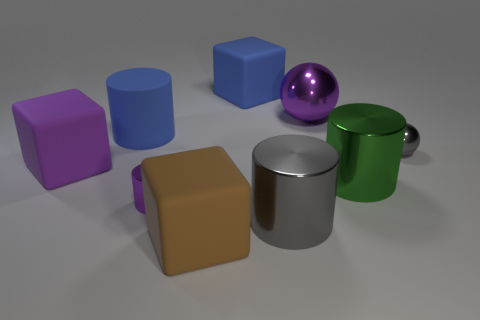There is a small shiny cylinder; does it have the same color as the big metal object to the right of the purple metal sphere?
Make the answer very short. No. Is there another green cylinder made of the same material as the tiny cylinder?
Your answer should be very brief. Yes. What number of blue metal spheres are there?
Make the answer very short. 0. What material is the large cylinder that is to the left of the big blue thing that is behind the big blue matte cylinder made of?
Your response must be concise. Rubber. The other big cylinder that is made of the same material as the large gray cylinder is what color?
Offer a terse response. Green. The rubber object that is the same color as the big metallic sphere is what shape?
Provide a short and direct response. Cube. There is a matte block that is left of the brown cube; is it the same size as the gray metal object that is behind the green metal thing?
Ensure brevity in your answer.  No. How many spheres are big gray metal objects or purple matte objects?
Your answer should be very brief. 0. Is the material of the small object right of the tiny metal cylinder the same as the tiny purple object?
Ensure brevity in your answer.  Yes. What number of other objects are the same size as the purple rubber object?
Offer a terse response. 6. 